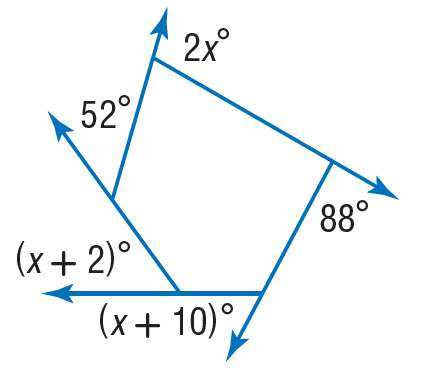Question: Find the value of x in the diagram.
Choices:
A. 12
B. 52
C. 88
D. 120
Answer with the letter. Answer: B 